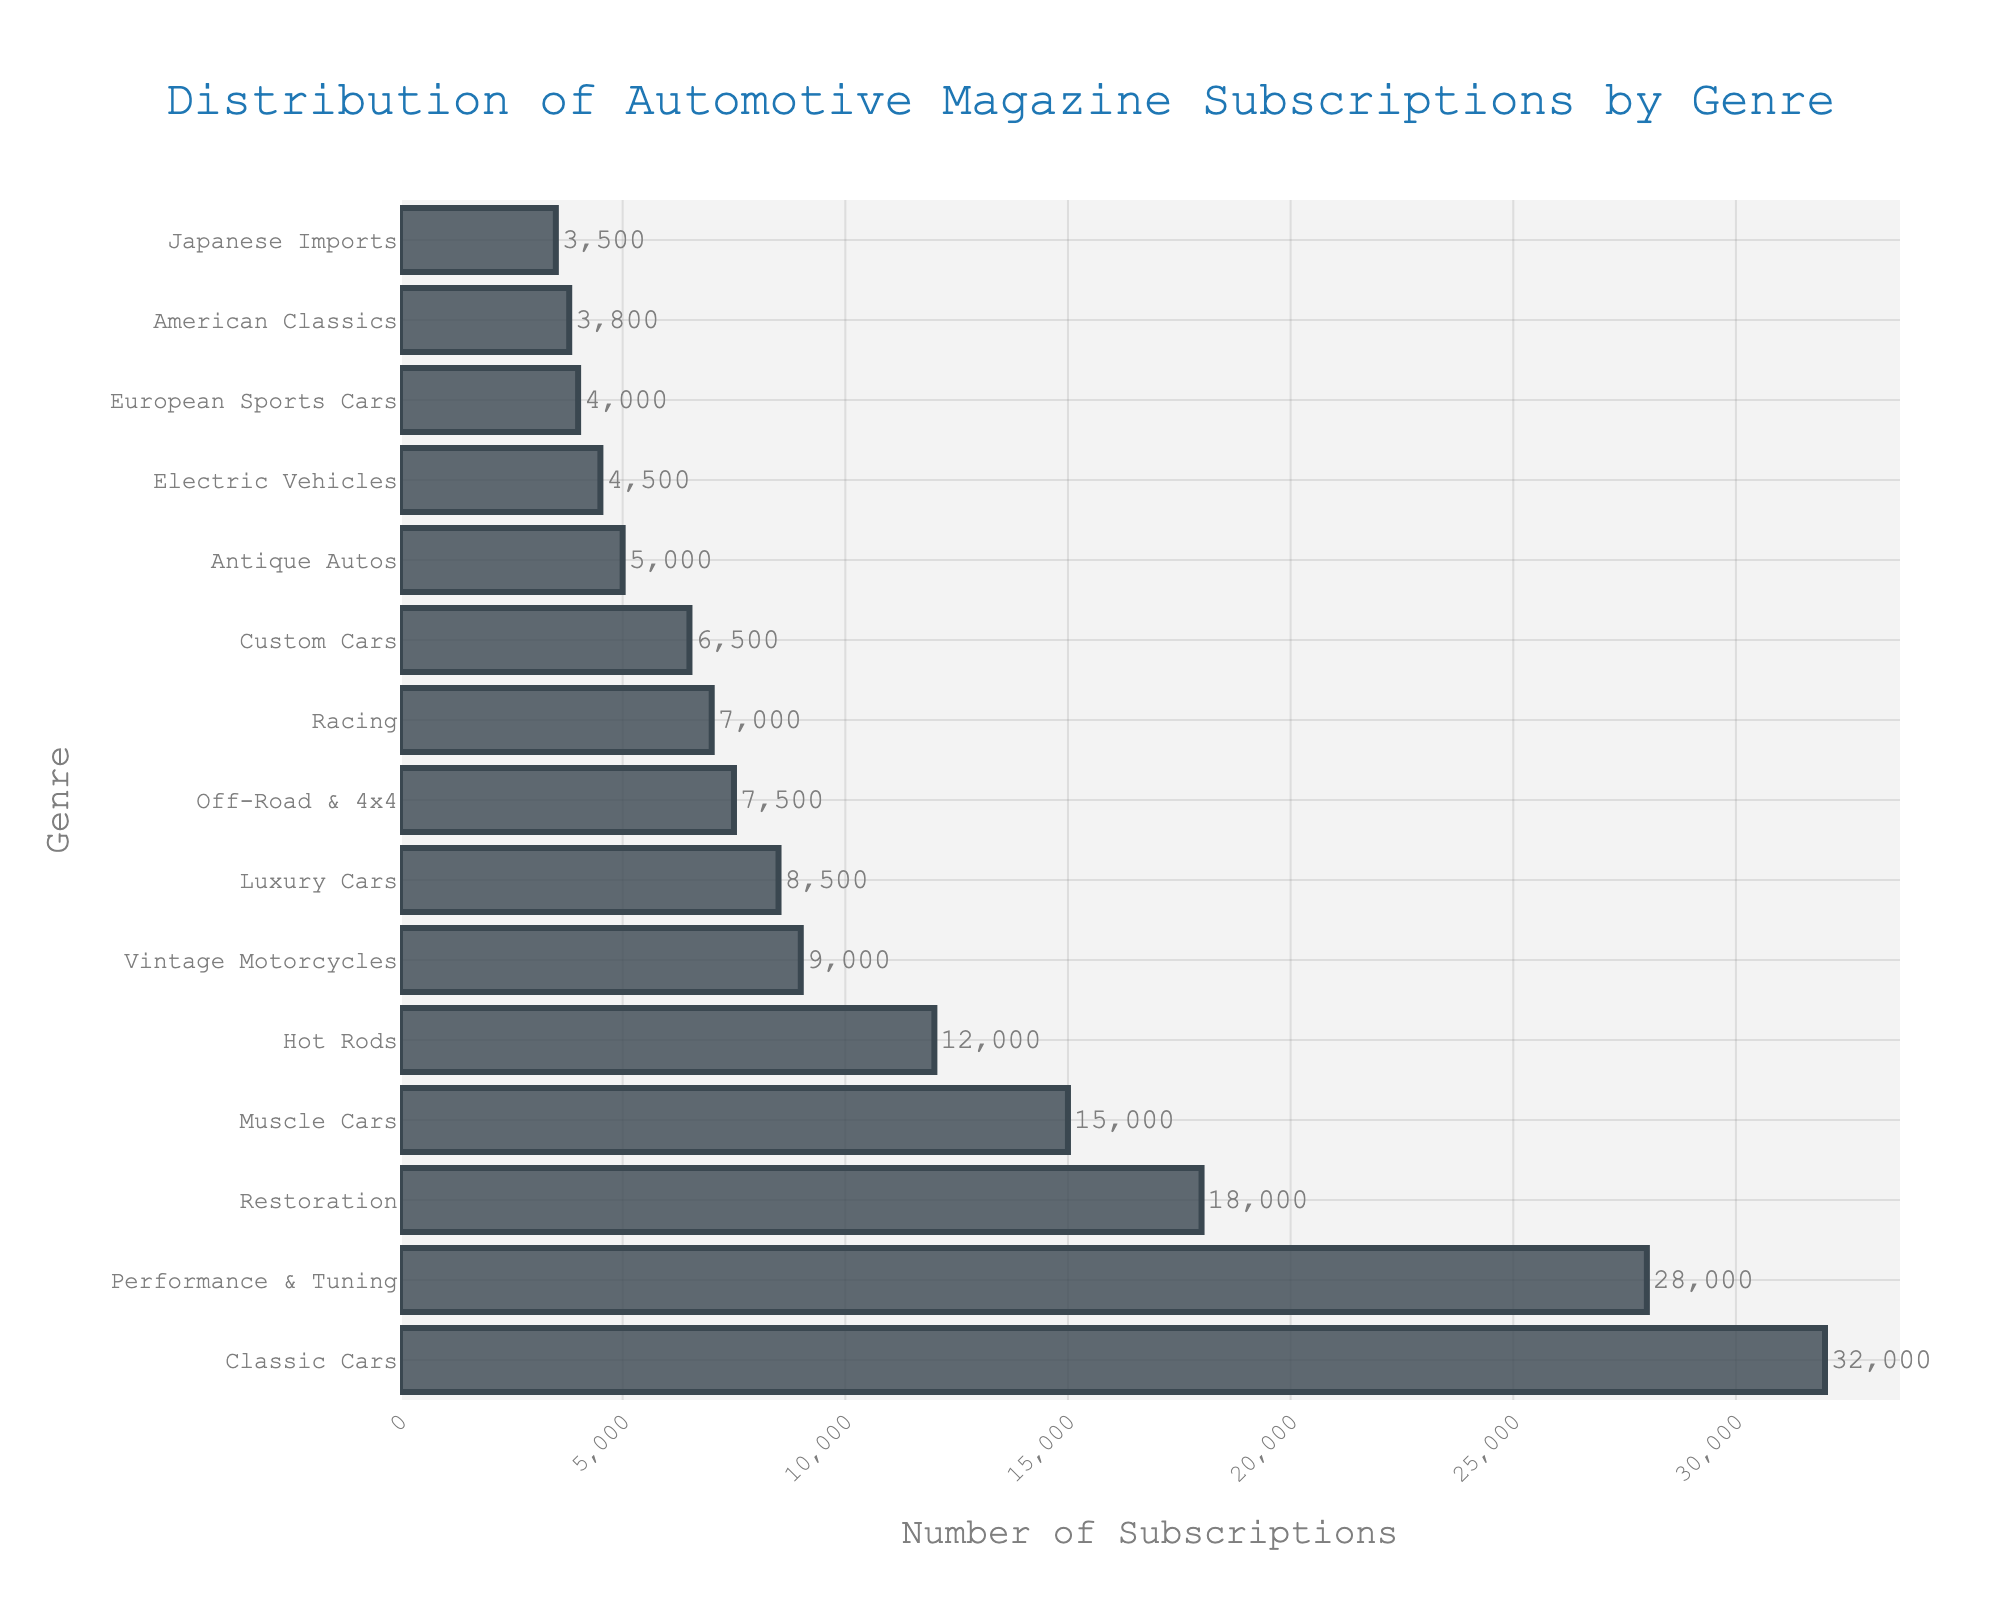Which genre has the highest number of subscriptions? By looking at the bar chart, we can see that the "Classic Cars" genre has the longest bar, indicating it has the highest number of subscriptions.
Answer: Classic Cars Which genre has the least number of subscriptions? The shortest bar on the chart corresponds to "Japanese Imports," indicating it has the least number of subscriptions.
Answer: Japanese Imports What is the difference in subscriptions between the "Classic Cars" and "Performance & Tuning" genres? The "Classic Cars" genre has 32,000 subscriptions, while the "Performance & Tuning" genre has 28,000 subscriptions. The difference is 32,000 - 28,000.
Answer: 4,000 How many more subscriptions does the "Restoration" genre have compared to the "Hot Rods" genre? The "Restoration" genre has 18,000 subscriptions, and the "Hot Rods" genre has 12,000 subscriptions. The difference is 18,000 - 12,000.
Answer: 6,000 Which genres have more than 20,000 subscriptions? The bars that stretch beyond the 20,000 mark represent the genres with more than 20,000 subscriptions. These are "Classic Cars" and "Performance & Tuning."
Answer: Classic Cars, Performance & Tuning What's the total number of subscriptions for the "Muscle Cars" and "Vintage Motorcycles" genres combined? The "Muscle Cars" genre has 15,000 subscriptions, and the "Vintage Motorcycles" genre has 9,000 subscriptions. The sum is 15,000 + 9,000.
Answer: 24,000 Are there more subscriptions to "Luxury Cars" or "Off-Road & 4x4"? By comparing the lengths of the bars, we see that the "Luxury Cars" genre has a longer bar than the "Off-Road & 4x4" genre, indicating more subscriptions.
Answer: Luxury Cars What is the average number of subscriptions for the top three genres? The top three genres are "Classic Cars" with 32,000, "Performance & Tuning" with 28,000, and "Restoration" with 18,000. The average is calculated as (32,000 + 28,000 + 18,000) / 3.
Answer: 26,000 What is the sum of subscriptions for the genres that have titles starting with 'A'? The genres are "Antique Autos" with 5,000 subscriptions, "American Classics" with 3,800, and "Asian Imports" with 3,500. The sum is 5,000 + 3,800 + 3,500.
Answer: 12,300 Which genre, "Electric Vehicles" or "European Sports Cars," has fewer subscriptions? By comparing the lengths of the bars, "European Sports Cars" is shorter than "Electric Vehicles," indicating fewer subscriptions.
Answer: European Sports Cars 